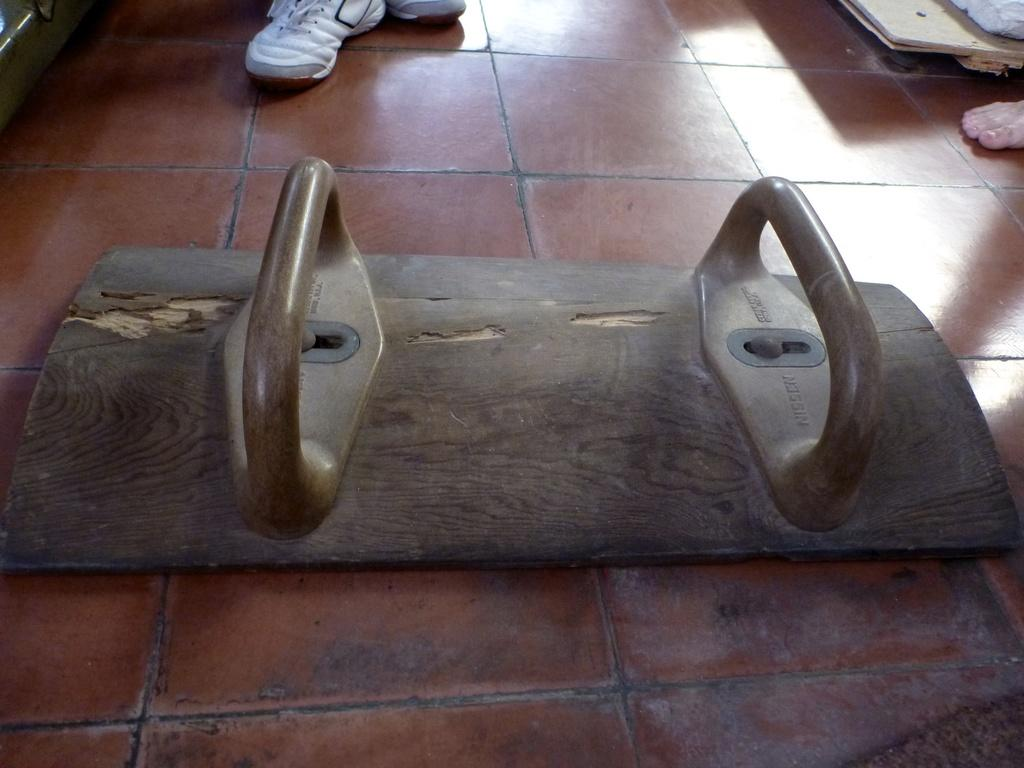What object is on the floor in the image? There is a wooden plank with handles on the floor. What else can be seen in the image? Human legs with shoes are visible, and another human leg is present. How many spiders are crawling on the wooden plank in the image? There are no spiders present on the wooden plank in the image. What type of vessel is being used to rest the wooden plank on in the image? There is no vessel present in the image; the wooden plank is on the floor. 